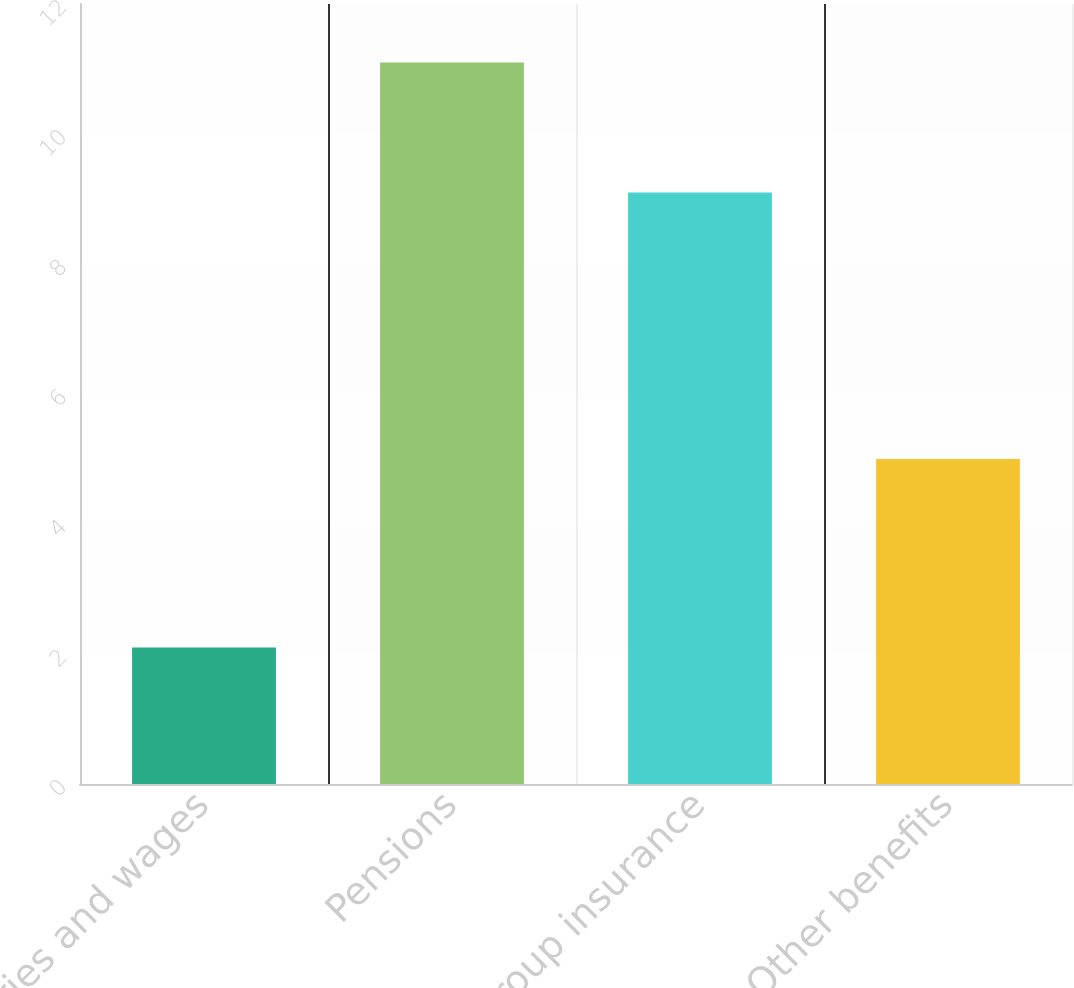Convert chart. <chart><loc_0><loc_0><loc_500><loc_500><bar_chart><fcel>Salaries and wages<fcel>Pensions<fcel>Group insurance<fcel>Other benefits<nl><fcel>2.1<fcel>11.1<fcel>9.1<fcel>5<nl></chart> 